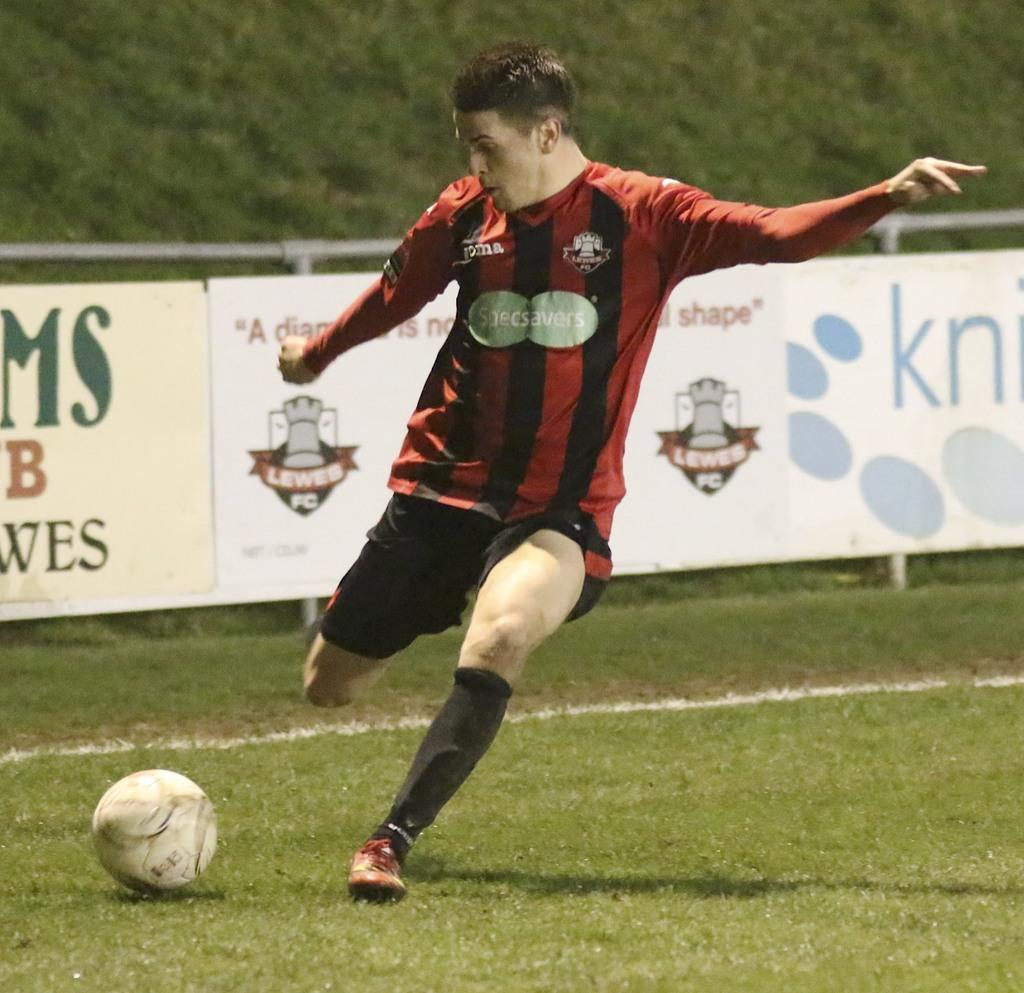Who is in the image? There is a person in the image. What is the person doing? The person is about to kick a football. What can be seen around the field in the image? There is a boundary around the field, and banners are present on the boundary. What type of surface is visible in the background of the image? There is grass visible in the background of the image. Can you see a crown on the person's head in the image? No, there is no crown visible on the person's head in the image. 